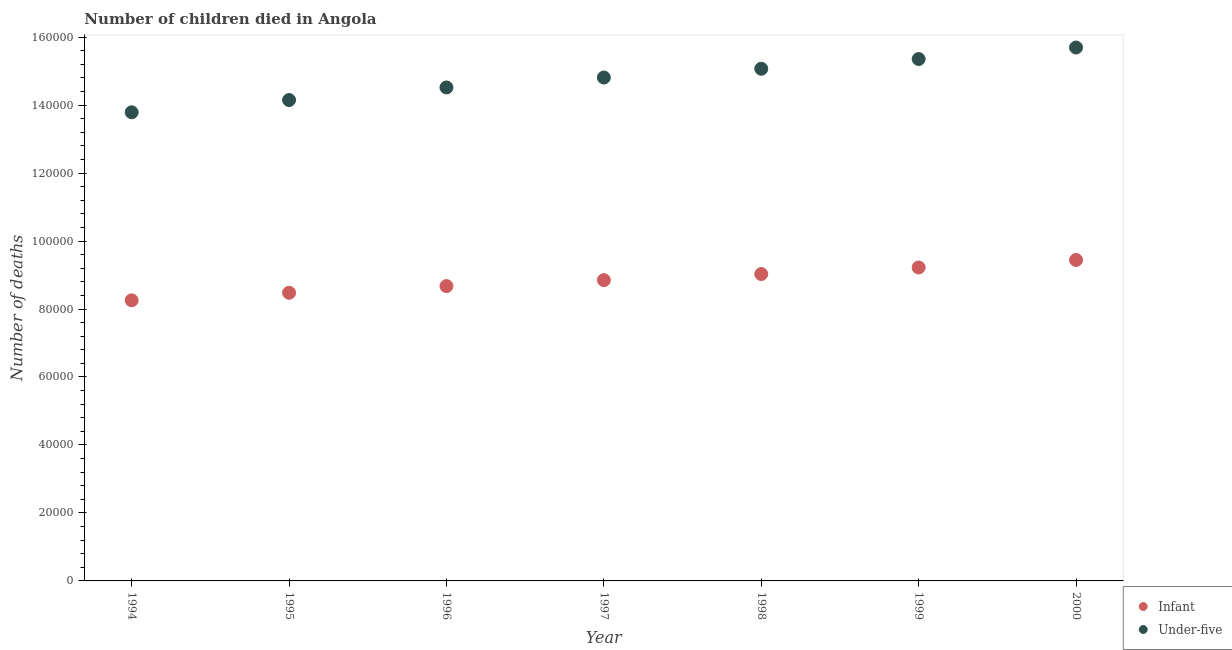How many different coloured dotlines are there?
Give a very brief answer. 2. Is the number of dotlines equal to the number of legend labels?
Your response must be concise. Yes. What is the number of infant deaths in 1999?
Your answer should be compact. 9.22e+04. Across all years, what is the maximum number of under-five deaths?
Offer a very short reply. 1.57e+05. Across all years, what is the minimum number of infant deaths?
Offer a terse response. 8.26e+04. In which year was the number of infant deaths maximum?
Provide a succinct answer. 2000. What is the total number of under-five deaths in the graph?
Ensure brevity in your answer.  1.03e+06. What is the difference between the number of under-five deaths in 1994 and that in 1997?
Ensure brevity in your answer.  -1.02e+04. What is the difference between the number of infant deaths in 1999 and the number of under-five deaths in 1995?
Offer a very short reply. -4.93e+04. What is the average number of under-five deaths per year?
Ensure brevity in your answer.  1.48e+05. In the year 1999, what is the difference between the number of infant deaths and number of under-five deaths?
Ensure brevity in your answer.  -6.13e+04. What is the ratio of the number of under-five deaths in 1996 to that in 1999?
Offer a very short reply. 0.95. Is the number of infant deaths in 1997 less than that in 1999?
Your response must be concise. Yes. What is the difference between the highest and the second highest number of under-five deaths?
Your response must be concise. 3387. What is the difference between the highest and the lowest number of infant deaths?
Keep it short and to the point. 1.19e+04. Does the number of under-five deaths monotonically increase over the years?
Offer a terse response. Yes. How many dotlines are there?
Give a very brief answer. 2. What is the difference between two consecutive major ticks on the Y-axis?
Provide a succinct answer. 2.00e+04. Are the values on the major ticks of Y-axis written in scientific E-notation?
Offer a very short reply. No. Does the graph contain any zero values?
Keep it short and to the point. No. Where does the legend appear in the graph?
Make the answer very short. Bottom right. How are the legend labels stacked?
Provide a succinct answer. Vertical. What is the title of the graph?
Give a very brief answer. Number of children died in Angola. What is the label or title of the Y-axis?
Provide a short and direct response. Number of deaths. What is the Number of deaths of Infant in 1994?
Provide a short and direct response. 8.26e+04. What is the Number of deaths in Under-five in 1994?
Your response must be concise. 1.38e+05. What is the Number of deaths of Infant in 1995?
Your answer should be compact. 8.48e+04. What is the Number of deaths in Under-five in 1995?
Your answer should be compact. 1.41e+05. What is the Number of deaths of Infant in 1996?
Make the answer very short. 8.68e+04. What is the Number of deaths of Under-five in 1996?
Your response must be concise. 1.45e+05. What is the Number of deaths of Infant in 1997?
Offer a terse response. 8.85e+04. What is the Number of deaths of Under-five in 1997?
Offer a terse response. 1.48e+05. What is the Number of deaths of Infant in 1998?
Your response must be concise. 9.03e+04. What is the Number of deaths in Under-five in 1998?
Ensure brevity in your answer.  1.51e+05. What is the Number of deaths in Infant in 1999?
Offer a very short reply. 9.22e+04. What is the Number of deaths of Under-five in 1999?
Provide a succinct answer. 1.54e+05. What is the Number of deaths in Infant in 2000?
Make the answer very short. 9.44e+04. What is the Number of deaths of Under-five in 2000?
Provide a succinct answer. 1.57e+05. Across all years, what is the maximum Number of deaths in Infant?
Provide a short and direct response. 9.44e+04. Across all years, what is the maximum Number of deaths in Under-five?
Make the answer very short. 1.57e+05. Across all years, what is the minimum Number of deaths in Infant?
Give a very brief answer. 8.26e+04. Across all years, what is the minimum Number of deaths of Under-five?
Give a very brief answer. 1.38e+05. What is the total Number of deaths of Infant in the graph?
Your answer should be very brief. 6.20e+05. What is the total Number of deaths in Under-five in the graph?
Your answer should be very brief. 1.03e+06. What is the difference between the Number of deaths of Infant in 1994 and that in 1995?
Give a very brief answer. -2212. What is the difference between the Number of deaths of Under-five in 1994 and that in 1995?
Keep it short and to the point. -3605. What is the difference between the Number of deaths of Infant in 1994 and that in 1996?
Ensure brevity in your answer.  -4186. What is the difference between the Number of deaths of Under-five in 1994 and that in 1996?
Give a very brief answer. -7307. What is the difference between the Number of deaths of Infant in 1994 and that in 1997?
Your response must be concise. -5935. What is the difference between the Number of deaths in Under-five in 1994 and that in 1997?
Offer a terse response. -1.02e+04. What is the difference between the Number of deaths in Infant in 1994 and that in 1998?
Your response must be concise. -7731. What is the difference between the Number of deaths of Under-five in 1994 and that in 1998?
Give a very brief answer. -1.28e+04. What is the difference between the Number of deaths in Infant in 1994 and that in 1999?
Provide a short and direct response. -9656. What is the difference between the Number of deaths of Under-five in 1994 and that in 1999?
Make the answer very short. -1.57e+04. What is the difference between the Number of deaths of Infant in 1994 and that in 2000?
Your answer should be very brief. -1.19e+04. What is the difference between the Number of deaths in Under-five in 1994 and that in 2000?
Your answer should be compact. -1.91e+04. What is the difference between the Number of deaths of Infant in 1995 and that in 1996?
Give a very brief answer. -1974. What is the difference between the Number of deaths of Under-five in 1995 and that in 1996?
Offer a very short reply. -3702. What is the difference between the Number of deaths in Infant in 1995 and that in 1997?
Give a very brief answer. -3723. What is the difference between the Number of deaths of Under-five in 1995 and that in 1997?
Make the answer very short. -6624. What is the difference between the Number of deaths of Infant in 1995 and that in 1998?
Your answer should be compact. -5519. What is the difference between the Number of deaths in Under-five in 1995 and that in 1998?
Give a very brief answer. -9205. What is the difference between the Number of deaths of Infant in 1995 and that in 1999?
Make the answer very short. -7444. What is the difference between the Number of deaths in Under-five in 1995 and that in 1999?
Make the answer very short. -1.21e+04. What is the difference between the Number of deaths in Infant in 1995 and that in 2000?
Offer a terse response. -9655. What is the difference between the Number of deaths of Under-five in 1995 and that in 2000?
Give a very brief answer. -1.55e+04. What is the difference between the Number of deaths of Infant in 1996 and that in 1997?
Your answer should be compact. -1749. What is the difference between the Number of deaths of Under-five in 1996 and that in 1997?
Offer a very short reply. -2922. What is the difference between the Number of deaths in Infant in 1996 and that in 1998?
Offer a very short reply. -3545. What is the difference between the Number of deaths of Under-five in 1996 and that in 1998?
Your answer should be very brief. -5503. What is the difference between the Number of deaths in Infant in 1996 and that in 1999?
Give a very brief answer. -5470. What is the difference between the Number of deaths in Under-five in 1996 and that in 1999?
Ensure brevity in your answer.  -8365. What is the difference between the Number of deaths in Infant in 1996 and that in 2000?
Your answer should be very brief. -7681. What is the difference between the Number of deaths of Under-five in 1996 and that in 2000?
Make the answer very short. -1.18e+04. What is the difference between the Number of deaths in Infant in 1997 and that in 1998?
Ensure brevity in your answer.  -1796. What is the difference between the Number of deaths of Under-five in 1997 and that in 1998?
Provide a succinct answer. -2581. What is the difference between the Number of deaths in Infant in 1997 and that in 1999?
Your response must be concise. -3721. What is the difference between the Number of deaths of Under-five in 1997 and that in 1999?
Your answer should be very brief. -5443. What is the difference between the Number of deaths of Infant in 1997 and that in 2000?
Give a very brief answer. -5932. What is the difference between the Number of deaths in Under-five in 1997 and that in 2000?
Your answer should be very brief. -8830. What is the difference between the Number of deaths in Infant in 1998 and that in 1999?
Offer a very short reply. -1925. What is the difference between the Number of deaths in Under-five in 1998 and that in 1999?
Your answer should be compact. -2862. What is the difference between the Number of deaths of Infant in 1998 and that in 2000?
Keep it short and to the point. -4136. What is the difference between the Number of deaths in Under-five in 1998 and that in 2000?
Your answer should be very brief. -6249. What is the difference between the Number of deaths of Infant in 1999 and that in 2000?
Your answer should be compact. -2211. What is the difference between the Number of deaths in Under-five in 1999 and that in 2000?
Provide a short and direct response. -3387. What is the difference between the Number of deaths of Infant in 1994 and the Number of deaths of Under-five in 1995?
Your answer should be compact. -5.89e+04. What is the difference between the Number of deaths of Infant in 1994 and the Number of deaths of Under-five in 1996?
Make the answer very short. -6.26e+04. What is the difference between the Number of deaths in Infant in 1994 and the Number of deaths in Under-five in 1997?
Offer a very short reply. -6.55e+04. What is the difference between the Number of deaths of Infant in 1994 and the Number of deaths of Under-five in 1998?
Give a very brief answer. -6.81e+04. What is the difference between the Number of deaths in Infant in 1994 and the Number of deaths in Under-five in 1999?
Keep it short and to the point. -7.10e+04. What is the difference between the Number of deaths in Infant in 1994 and the Number of deaths in Under-five in 2000?
Offer a very short reply. -7.44e+04. What is the difference between the Number of deaths in Infant in 1995 and the Number of deaths in Under-five in 1996?
Provide a succinct answer. -6.04e+04. What is the difference between the Number of deaths in Infant in 1995 and the Number of deaths in Under-five in 1997?
Provide a short and direct response. -6.33e+04. What is the difference between the Number of deaths in Infant in 1995 and the Number of deaths in Under-five in 1998?
Make the answer very short. -6.59e+04. What is the difference between the Number of deaths in Infant in 1995 and the Number of deaths in Under-five in 1999?
Your answer should be very brief. -6.88e+04. What is the difference between the Number of deaths in Infant in 1995 and the Number of deaths in Under-five in 2000?
Give a very brief answer. -7.22e+04. What is the difference between the Number of deaths in Infant in 1996 and the Number of deaths in Under-five in 1997?
Make the answer very short. -6.14e+04. What is the difference between the Number of deaths in Infant in 1996 and the Number of deaths in Under-five in 1998?
Offer a very short reply. -6.39e+04. What is the difference between the Number of deaths in Infant in 1996 and the Number of deaths in Under-five in 1999?
Offer a terse response. -6.68e+04. What is the difference between the Number of deaths of Infant in 1996 and the Number of deaths of Under-five in 2000?
Your answer should be compact. -7.02e+04. What is the difference between the Number of deaths in Infant in 1997 and the Number of deaths in Under-five in 1998?
Offer a terse response. -6.22e+04. What is the difference between the Number of deaths of Infant in 1997 and the Number of deaths of Under-five in 1999?
Give a very brief answer. -6.51e+04. What is the difference between the Number of deaths in Infant in 1997 and the Number of deaths in Under-five in 2000?
Offer a terse response. -6.84e+04. What is the difference between the Number of deaths in Infant in 1998 and the Number of deaths in Under-five in 1999?
Your answer should be very brief. -6.33e+04. What is the difference between the Number of deaths in Infant in 1998 and the Number of deaths in Under-five in 2000?
Ensure brevity in your answer.  -6.66e+04. What is the difference between the Number of deaths in Infant in 1999 and the Number of deaths in Under-five in 2000?
Offer a terse response. -6.47e+04. What is the average Number of deaths of Infant per year?
Offer a very short reply. 8.85e+04. What is the average Number of deaths of Under-five per year?
Provide a short and direct response. 1.48e+05. In the year 1994, what is the difference between the Number of deaths in Infant and Number of deaths in Under-five?
Keep it short and to the point. -5.53e+04. In the year 1995, what is the difference between the Number of deaths in Infant and Number of deaths in Under-five?
Your response must be concise. -5.67e+04. In the year 1996, what is the difference between the Number of deaths of Infant and Number of deaths of Under-five?
Your response must be concise. -5.84e+04. In the year 1997, what is the difference between the Number of deaths of Infant and Number of deaths of Under-five?
Give a very brief answer. -5.96e+04. In the year 1998, what is the difference between the Number of deaths in Infant and Number of deaths in Under-five?
Ensure brevity in your answer.  -6.04e+04. In the year 1999, what is the difference between the Number of deaths in Infant and Number of deaths in Under-five?
Give a very brief answer. -6.13e+04. In the year 2000, what is the difference between the Number of deaths of Infant and Number of deaths of Under-five?
Keep it short and to the point. -6.25e+04. What is the ratio of the Number of deaths of Infant in 1994 to that in 1995?
Ensure brevity in your answer.  0.97. What is the ratio of the Number of deaths of Under-five in 1994 to that in 1995?
Your answer should be very brief. 0.97. What is the ratio of the Number of deaths of Infant in 1994 to that in 1996?
Keep it short and to the point. 0.95. What is the ratio of the Number of deaths in Under-five in 1994 to that in 1996?
Make the answer very short. 0.95. What is the ratio of the Number of deaths in Infant in 1994 to that in 1997?
Your answer should be very brief. 0.93. What is the ratio of the Number of deaths in Under-five in 1994 to that in 1997?
Offer a very short reply. 0.93. What is the ratio of the Number of deaths in Infant in 1994 to that in 1998?
Offer a terse response. 0.91. What is the ratio of the Number of deaths in Under-five in 1994 to that in 1998?
Ensure brevity in your answer.  0.92. What is the ratio of the Number of deaths in Infant in 1994 to that in 1999?
Ensure brevity in your answer.  0.9. What is the ratio of the Number of deaths of Under-five in 1994 to that in 1999?
Give a very brief answer. 0.9. What is the ratio of the Number of deaths in Infant in 1994 to that in 2000?
Provide a short and direct response. 0.87. What is the ratio of the Number of deaths in Under-five in 1994 to that in 2000?
Make the answer very short. 0.88. What is the ratio of the Number of deaths in Infant in 1995 to that in 1996?
Your answer should be compact. 0.98. What is the ratio of the Number of deaths of Under-five in 1995 to that in 1996?
Your answer should be compact. 0.97. What is the ratio of the Number of deaths of Infant in 1995 to that in 1997?
Keep it short and to the point. 0.96. What is the ratio of the Number of deaths in Under-five in 1995 to that in 1997?
Your response must be concise. 0.96. What is the ratio of the Number of deaths of Infant in 1995 to that in 1998?
Your answer should be compact. 0.94. What is the ratio of the Number of deaths in Under-five in 1995 to that in 1998?
Provide a short and direct response. 0.94. What is the ratio of the Number of deaths in Infant in 1995 to that in 1999?
Your response must be concise. 0.92. What is the ratio of the Number of deaths of Under-five in 1995 to that in 1999?
Your answer should be very brief. 0.92. What is the ratio of the Number of deaths of Infant in 1995 to that in 2000?
Your answer should be compact. 0.9. What is the ratio of the Number of deaths in Under-five in 1995 to that in 2000?
Provide a short and direct response. 0.9. What is the ratio of the Number of deaths of Infant in 1996 to that in 1997?
Your response must be concise. 0.98. What is the ratio of the Number of deaths in Under-five in 1996 to that in 1997?
Your response must be concise. 0.98. What is the ratio of the Number of deaths in Infant in 1996 to that in 1998?
Your response must be concise. 0.96. What is the ratio of the Number of deaths of Under-five in 1996 to that in 1998?
Your answer should be compact. 0.96. What is the ratio of the Number of deaths in Infant in 1996 to that in 1999?
Your answer should be very brief. 0.94. What is the ratio of the Number of deaths of Under-five in 1996 to that in 1999?
Your response must be concise. 0.95. What is the ratio of the Number of deaths of Infant in 1996 to that in 2000?
Your answer should be compact. 0.92. What is the ratio of the Number of deaths in Under-five in 1996 to that in 2000?
Provide a succinct answer. 0.93. What is the ratio of the Number of deaths of Infant in 1997 to that in 1998?
Your response must be concise. 0.98. What is the ratio of the Number of deaths in Under-five in 1997 to that in 1998?
Ensure brevity in your answer.  0.98. What is the ratio of the Number of deaths of Infant in 1997 to that in 1999?
Offer a very short reply. 0.96. What is the ratio of the Number of deaths of Under-five in 1997 to that in 1999?
Provide a short and direct response. 0.96. What is the ratio of the Number of deaths of Infant in 1997 to that in 2000?
Make the answer very short. 0.94. What is the ratio of the Number of deaths of Under-five in 1997 to that in 2000?
Provide a succinct answer. 0.94. What is the ratio of the Number of deaths in Infant in 1998 to that in 1999?
Offer a terse response. 0.98. What is the ratio of the Number of deaths in Under-five in 1998 to that in 1999?
Ensure brevity in your answer.  0.98. What is the ratio of the Number of deaths of Infant in 1998 to that in 2000?
Your response must be concise. 0.96. What is the ratio of the Number of deaths of Under-five in 1998 to that in 2000?
Offer a very short reply. 0.96. What is the ratio of the Number of deaths in Infant in 1999 to that in 2000?
Your answer should be very brief. 0.98. What is the ratio of the Number of deaths in Under-five in 1999 to that in 2000?
Keep it short and to the point. 0.98. What is the difference between the highest and the second highest Number of deaths in Infant?
Ensure brevity in your answer.  2211. What is the difference between the highest and the second highest Number of deaths of Under-five?
Your response must be concise. 3387. What is the difference between the highest and the lowest Number of deaths of Infant?
Offer a very short reply. 1.19e+04. What is the difference between the highest and the lowest Number of deaths of Under-five?
Your answer should be very brief. 1.91e+04. 